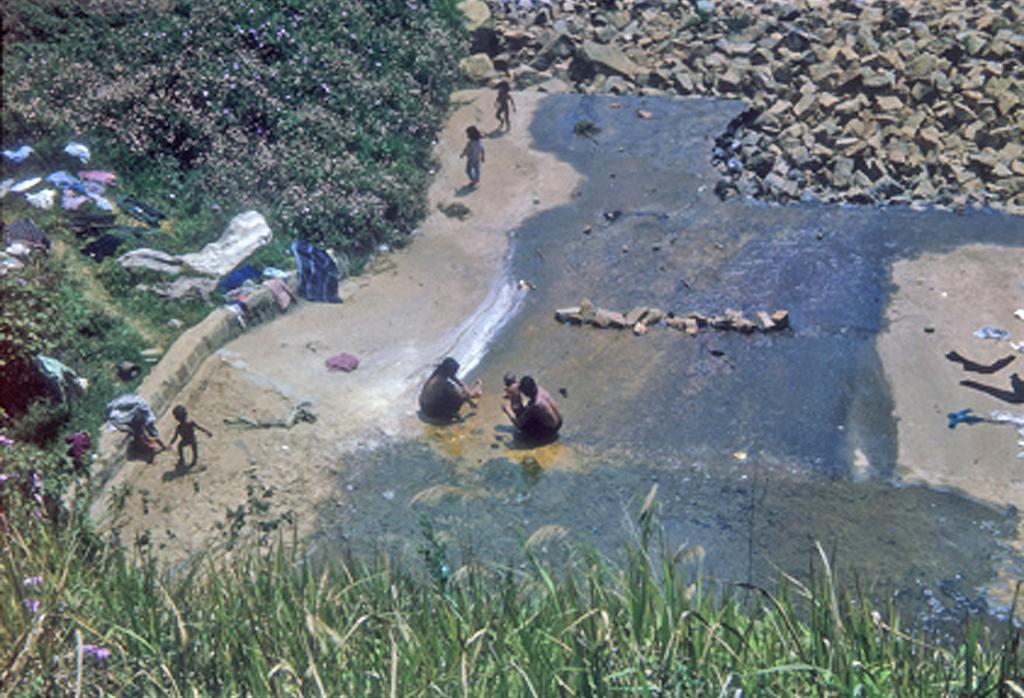Please provide a concise description of this image. At the bottom of the image we can see plants and flowers. In the background of the image we can see water, people, plants, flowers, stones, clothes and other objects. 